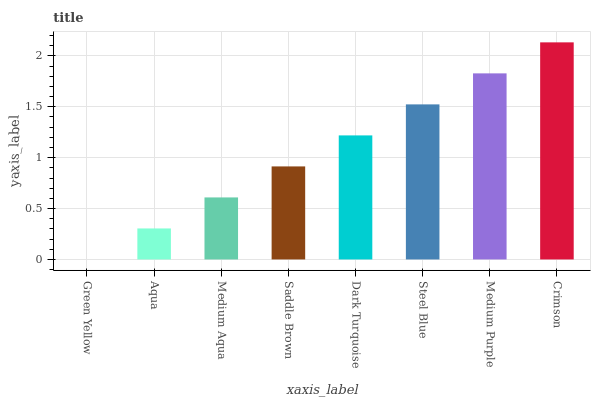Is Aqua the minimum?
Answer yes or no. No. Is Aqua the maximum?
Answer yes or no. No. Is Aqua greater than Green Yellow?
Answer yes or no. Yes. Is Green Yellow less than Aqua?
Answer yes or no. Yes. Is Green Yellow greater than Aqua?
Answer yes or no. No. Is Aqua less than Green Yellow?
Answer yes or no. No. Is Dark Turquoise the high median?
Answer yes or no. Yes. Is Saddle Brown the low median?
Answer yes or no. Yes. Is Aqua the high median?
Answer yes or no. No. Is Steel Blue the low median?
Answer yes or no. No. 